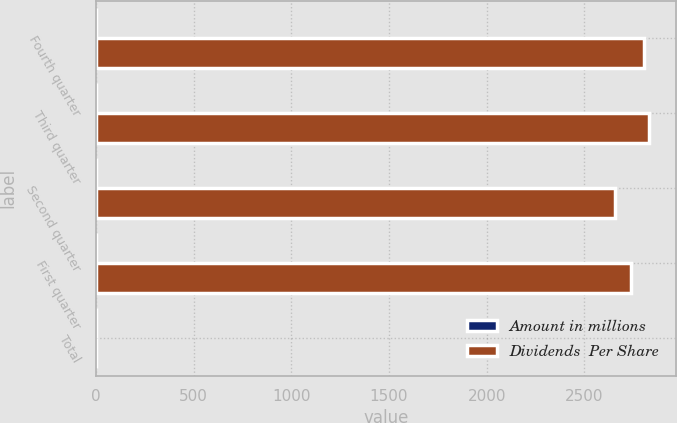<chart> <loc_0><loc_0><loc_500><loc_500><stacked_bar_chart><ecel><fcel>Fourth quarter<fcel>Third quarter<fcel>Second quarter<fcel>First quarter<fcel>Total<nl><fcel>Amount in millions<fcel>0.47<fcel>0.47<fcel>0.44<fcel>0.44<fcel>1.82<nl><fcel>Dividends  Per Share<fcel>2807<fcel>2830<fcel>2655<fcel>2739<fcel>1.82<nl></chart> 